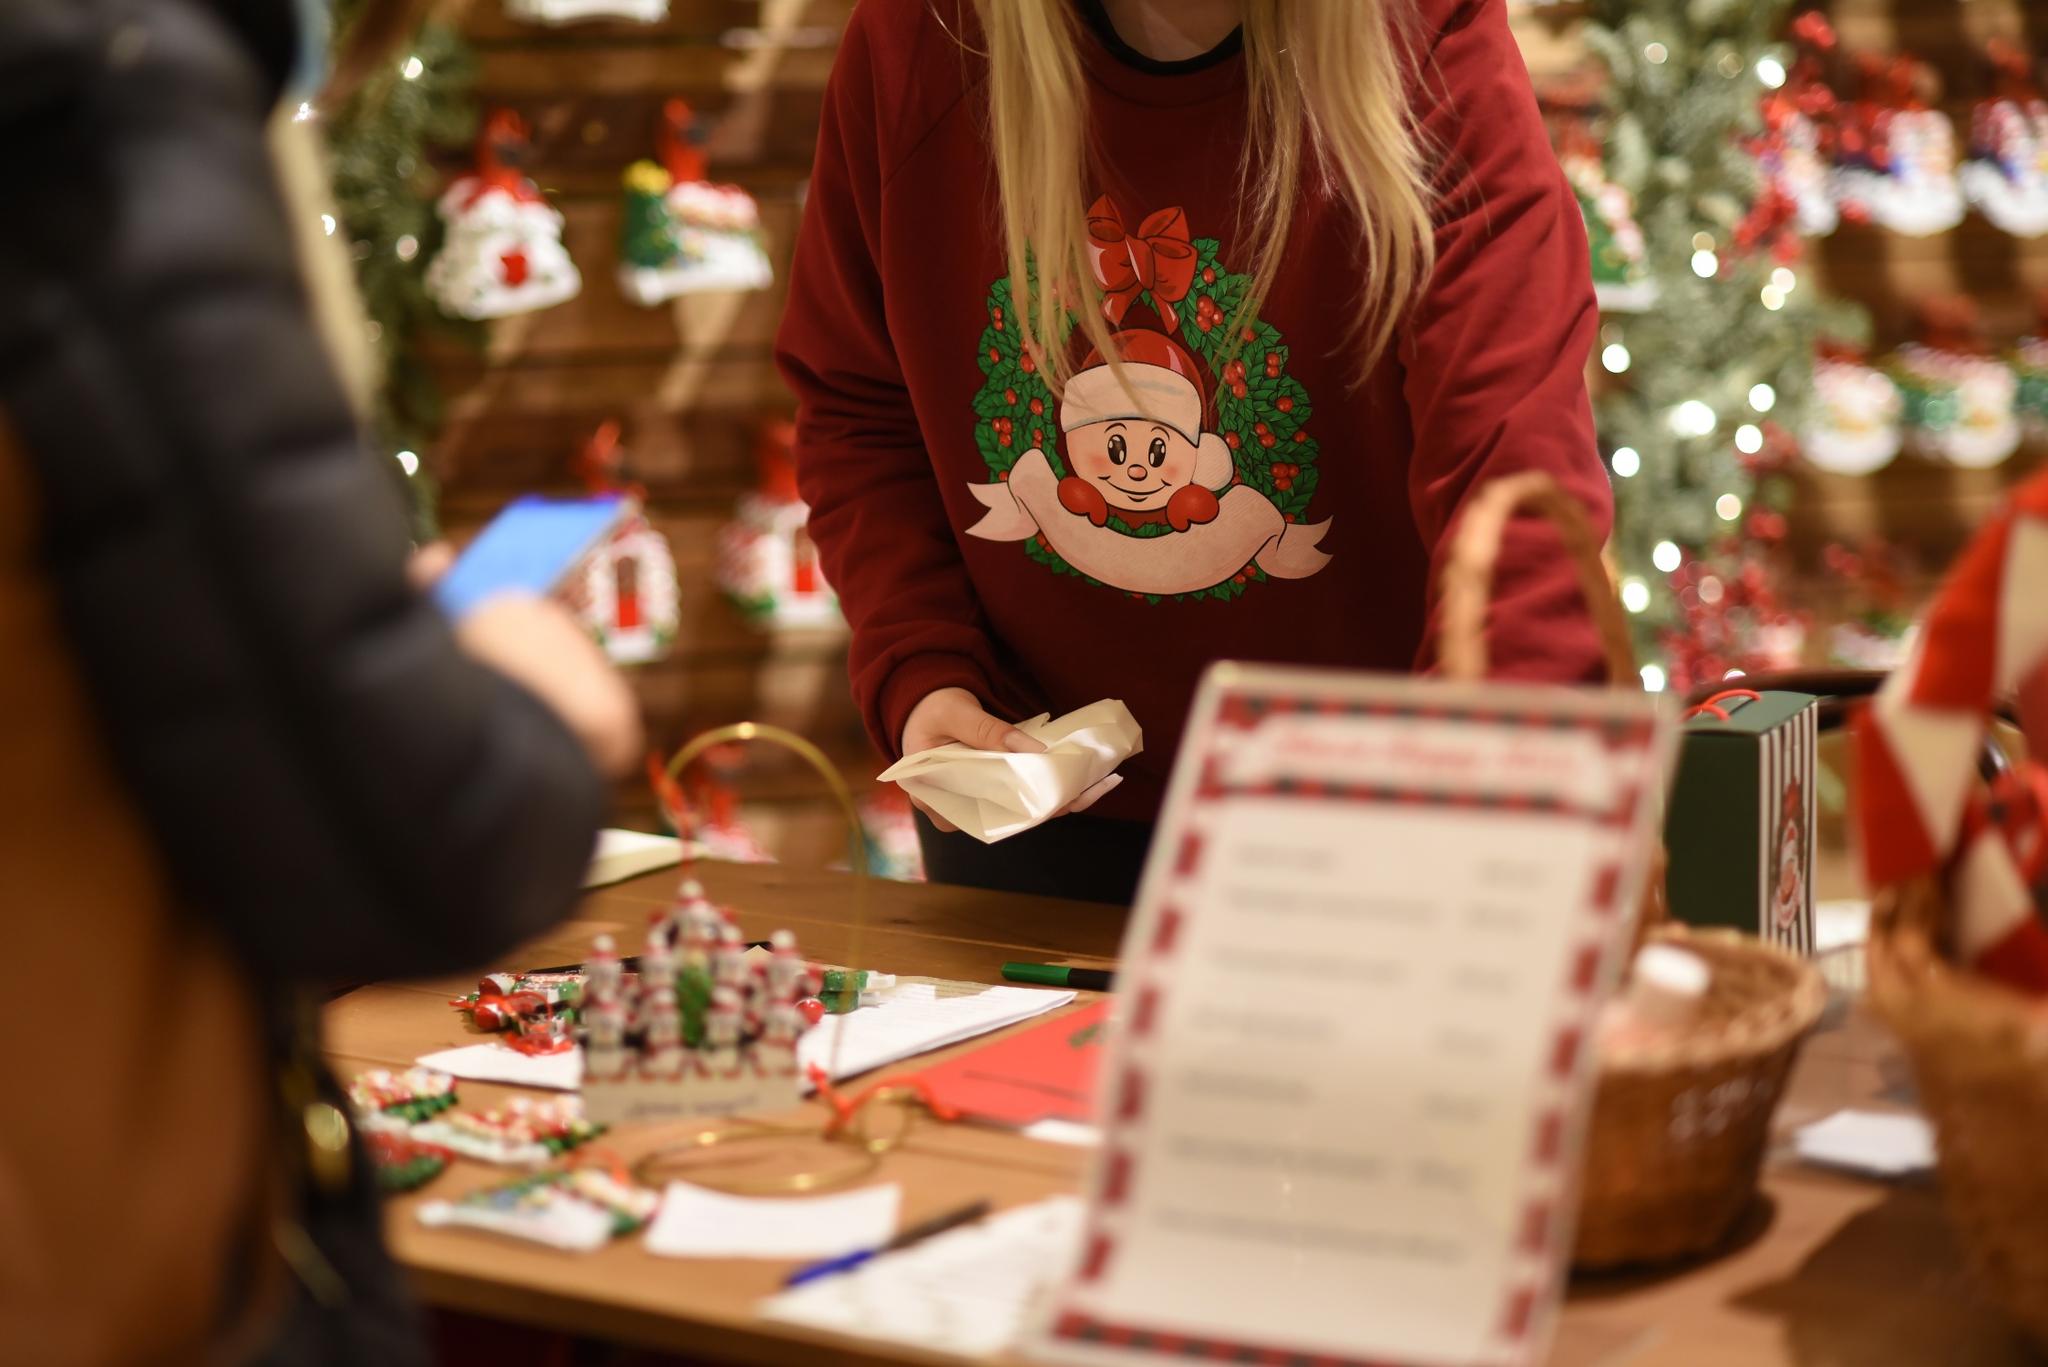What is this photo about'? In the image, a person is standing behind a festive wooden counter in what appears to be a cozy Christmas-themed store or gift shop. The individual is engaged in wrapping a present, carefully folding a piece of white tissue paper around it. They are wearing a festive red sweater decorated with a cheerful Christmas graphic, further enhancing the holiday spirit. The counter is adorned with various Christmas decorations and trinkets, contributing to the vibrant and joyous atmosphere. A basket filled with paper featuring red and white stripes can be seen to the right, adding more festive flair. In the background, there is a beautifully decorated Christmas tree accompanied by other holiday ornaments, all enhancing the overall festive ambiance. 